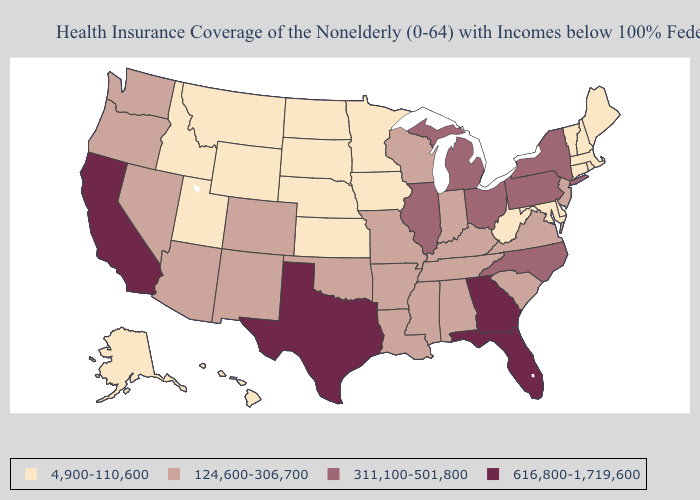How many symbols are there in the legend?
Be succinct. 4. What is the highest value in states that border South Carolina?
Give a very brief answer. 616,800-1,719,600. What is the lowest value in states that border New Mexico?
Keep it brief. 4,900-110,600. What is the value of Wisconsin?
Short answer required. 124,600-306,700. What is the value of Arizona?
Quick response, please. 124,600-306,700. Which states hav the highest value in the Northeast?
Keep it brief. New York, Pennsylvania. Name the states that have a value in the range 616,800-1,719,600?
Be succinct. California, Florida, Georgia, Texas. What is the lowest value in the Northeast?
Be succinct. 4,900-110,600. What is the highest value in the USA?
Concise answer only. 616,800-1,719,600. Name the states that have a value in the range 124,600-306,700?
Concise answer only. Alabama, Arizona, Arkansas, Colorado, Indiana, Kentucky, Louisiana, Mississippi, Missouri, Nevada, New Jersey, New Mexico, Oklahoma, Oregon, South Carolina, Tennessee, Virginia, Washington, Wisconsin. What is the highest value in the South ?
Write a very short answer. 616,800-1,719,600. Name the states that have a value in the range 4,900-110,600?
Concise answer only. Alaska, Connecticut, Delaware, Hawaii, Idaho, Iowa, Kansas, Maine, Maryland, Massachusetts, Minnesota, Montana, Nebraska, New Hampshire, North Dakota, Rhode Island, South Dakota, Utah, Vermont, West Virginia, Wyoming. Among the states that border Kansas , which have the highest value?
Be succinct. Colorado, Missouri, Oklahoma. Does Utah have a lower value than Connecticut?
Short answer required. No. What is the value of Louisiana?
Quick response, please. 124,600-306,700. 